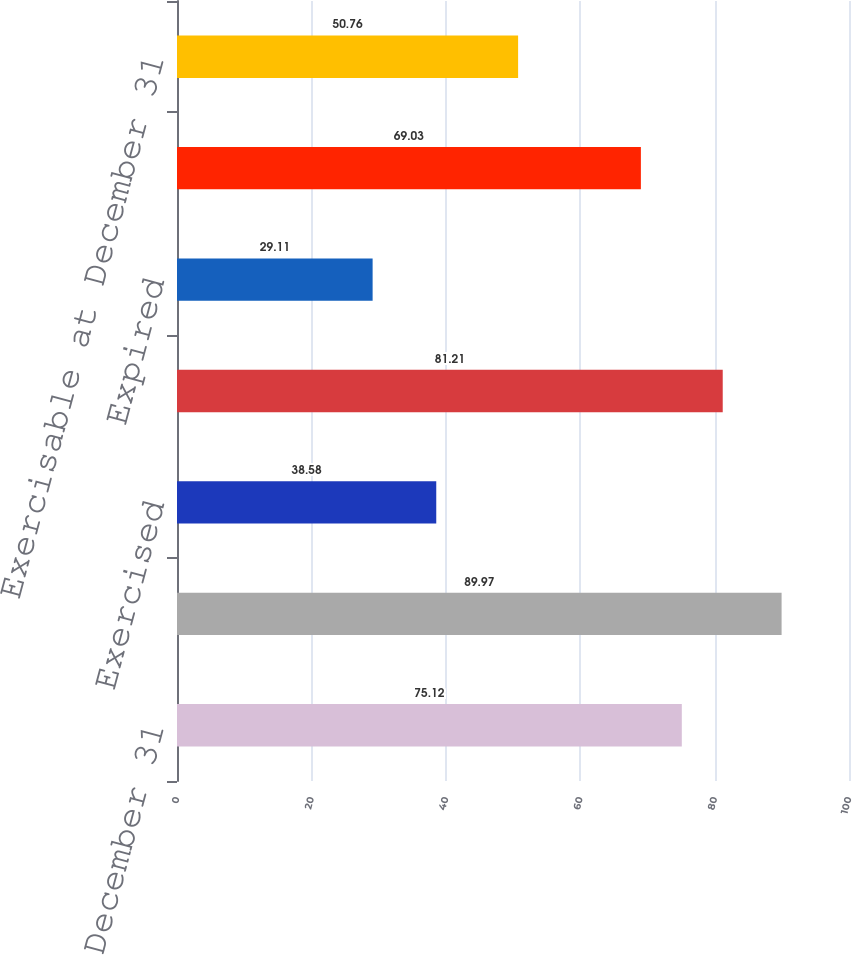<chart> <loc_0><loc_0><loc_500><loc_500><bar_chart><fcel>Outstanding at December 31<fcel>Granted<fcel>Exercised<fcel>Forfeited<fcel>Expired<fcel>Vested and expected to vest at<fcel>Exercisable at December 31<nl><fcel>75.12<fcel>89.97<fcel>38.58<fcel>81.21<fcel>29.11<fcel>69.03<fcel>50.76<nl></chart> 